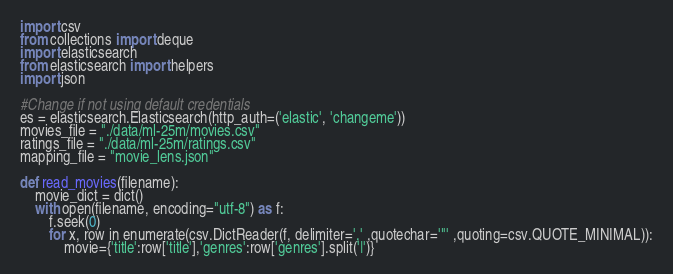Convert code to text. <code><loc_0><loc_0><loc_500><loc_500><_Python_>import csv
from collections import deque
import elasticsearch
from elasticsearch import helpers
import json

#Change if not using default credentials
es = elasticsearch.Elasticsearch(http_auth=('elastic', 'changeme'))
movies_file = "./data/ml-25m/movies.csv"
ratings_file = "./data/ml-25m/ratings.csv"
mapping_file = "movie_lens.json"

def read_movies(filename):
    movie_dict = dict()
    with open(filename, encoding="utf-8") as f:
        f.seek(0)
        for x, row in enumerate(csv.DictReader(f, delimiter=',' ,quotechar='"' ,quoting=csv.QUOTE_MINIMAL)):
            movie={'title':row['title'],'genres':row['genres'].split('|')}</code> 